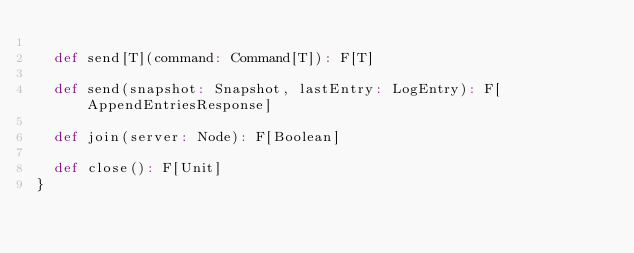<code> <loc_0><loc_0><loc_500><loc_500><_Scala_>
  def send[T](command: Command[T]): F[T]

  def send(snapshot: Snapshot, lastEntry: LogEntry): F[AppendEntriesResponse]

  def join(server: Node): F[Boolean]

  def close(): F[Unit]
}
</code> 